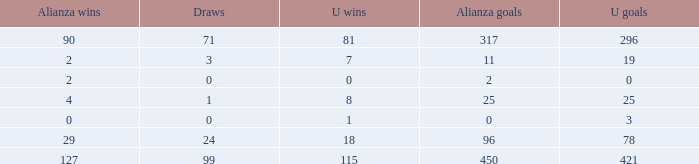What is the lowest Draws, when Alianza Goals is less than 317, when U Goals is less than 3, and when Alianza Wins is less than 2? None. 